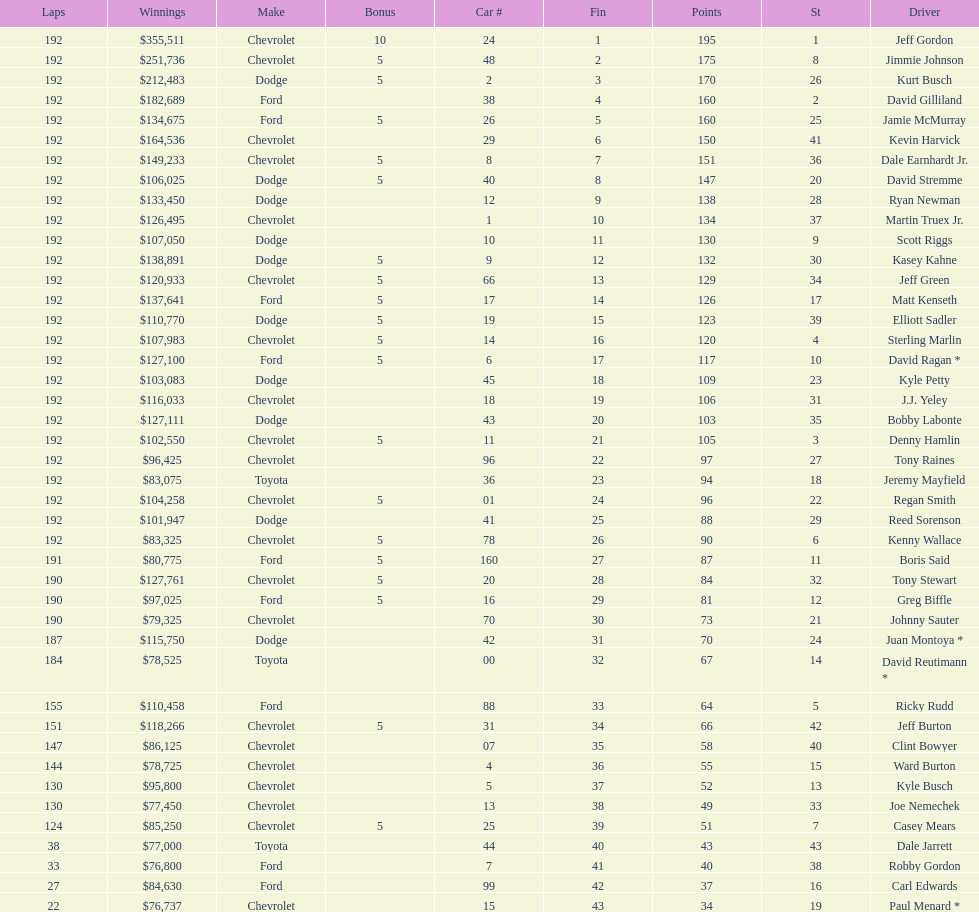Which driver received the smallest amount of earnings? Paul Menard *. 